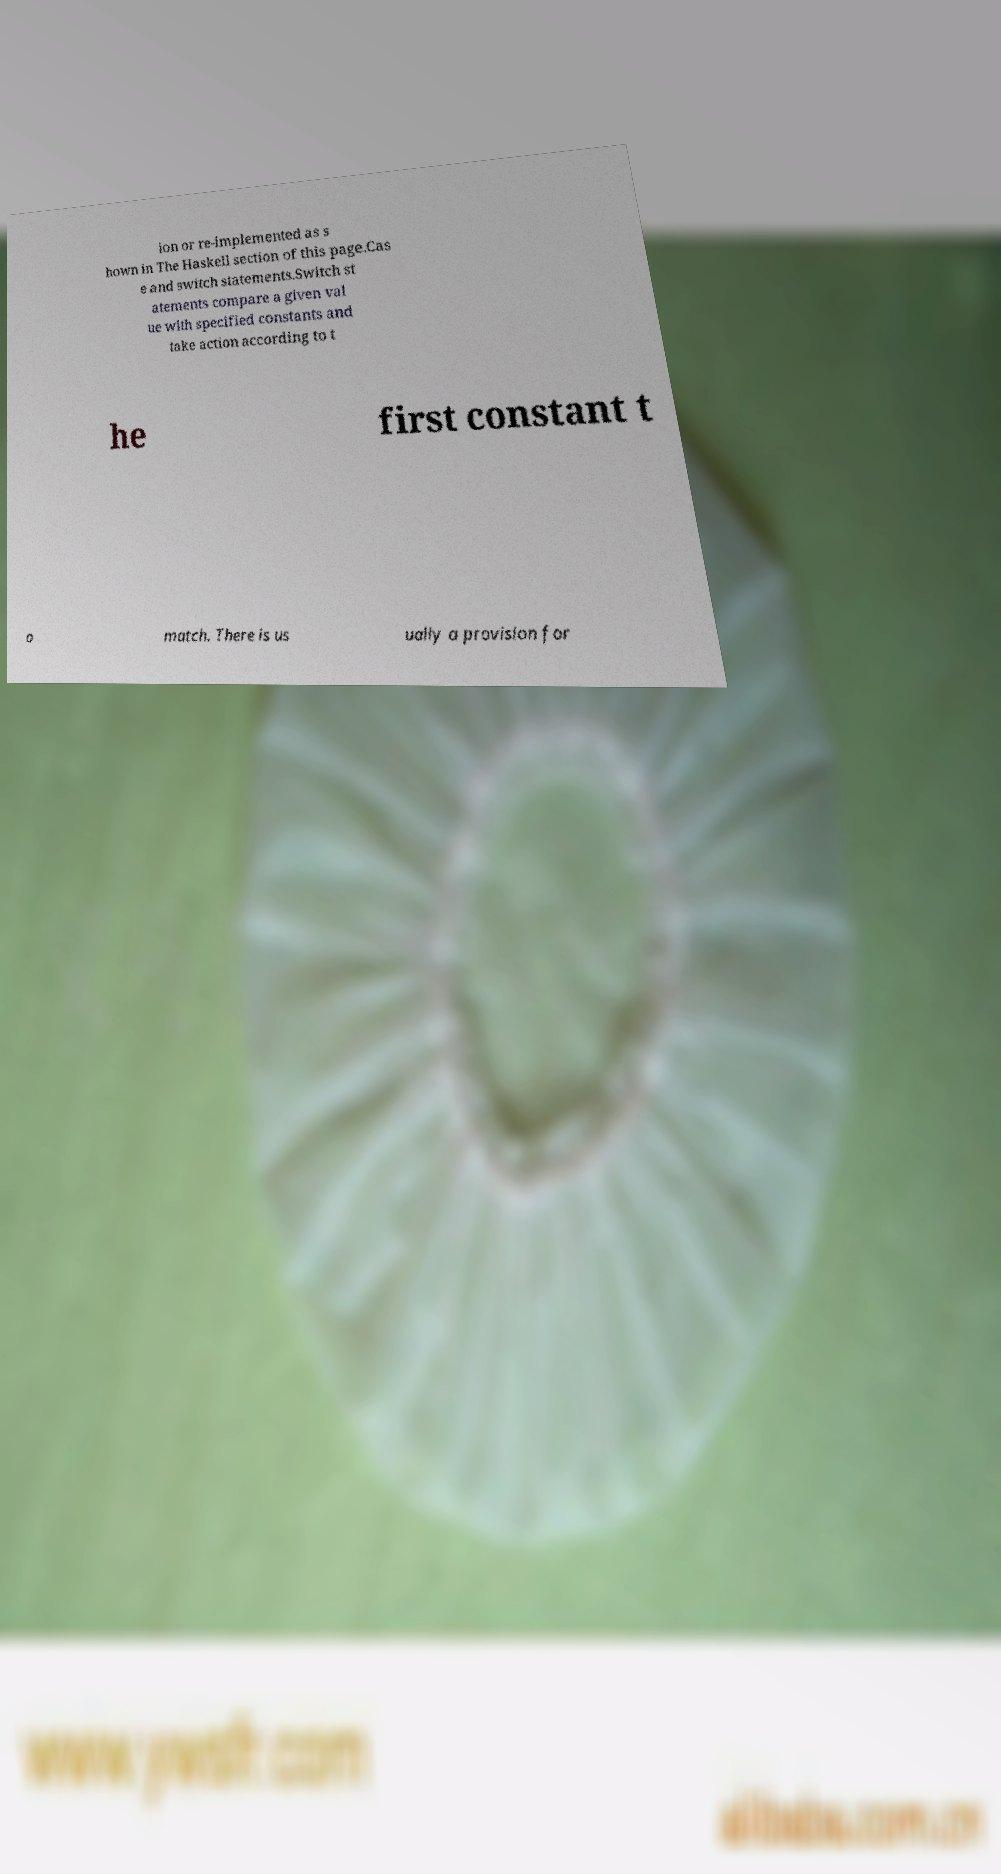Can you read and provide the text displayed in the image?This photo seems to have some interesting text. Can you extract and type it out for me? ion or re-implemented as s hown in The Haskell section of this page.Cas e and switch statements.Switch st atements compare a given val ue with specified constants and take action according to t he first constant t o match. There is us ually a provision for 